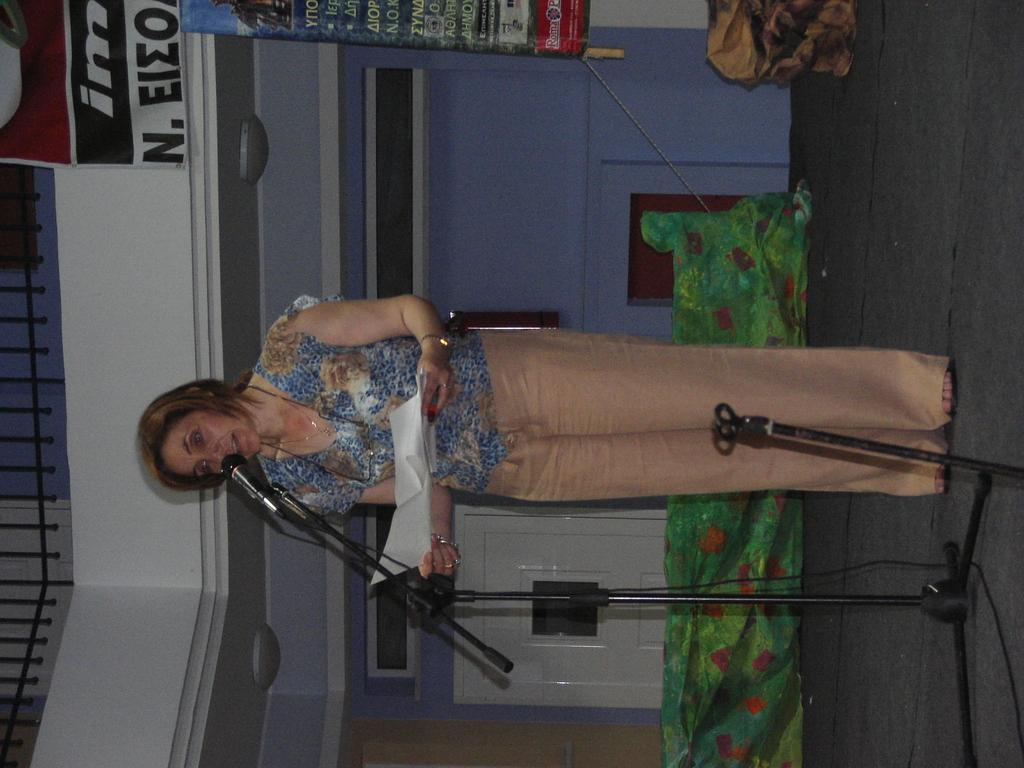How would you summarize this image in a sentence or two? In this image we can see a woman holding a paper. In front of her there is a mic with a stand. In the background, we can see a wall. At the top we can see the banners with text. On the left side, we can see the metal railing. 